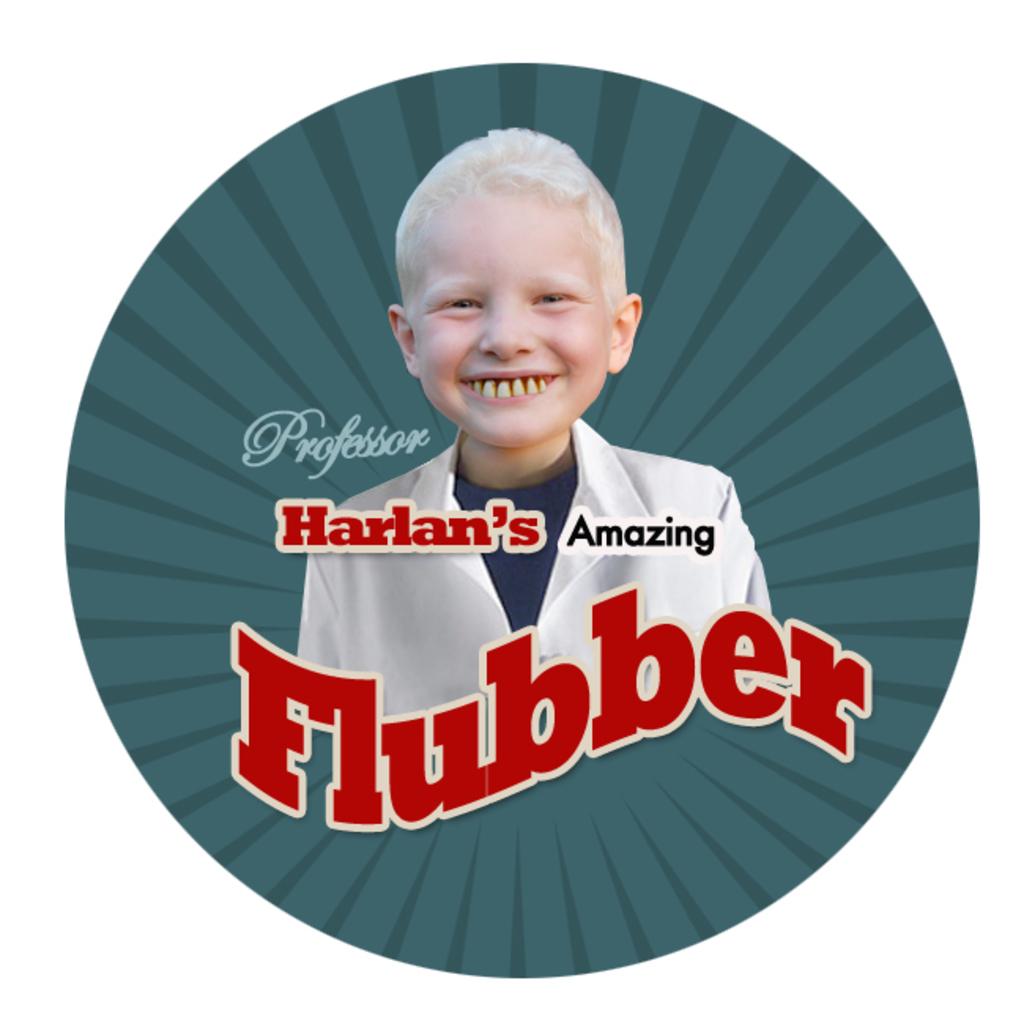What word is in black?
Your response must be concise. Amazing. Whose flubber is it?
Give a very brief answer. Harlan's. 